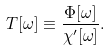Convert formula to latex. <formula><loc_0><loc_0><loc_500><loc_500>T [ \omega ] \equiv \frac { \Phi [ \omega ] } { \chi ^ { \prime } [ \omega ] } .</formula> 